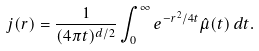<formula> <loc_0><loc_0><loc_500><loc_500>j ( r ) = \frac { 1 } { ( 4 \pi t ) ^ { d / 2 } } \int _ { 0 } ^ { \infty } e ^ { - r ^ { 2 } / 4 t } \hat { \mu } ( t ) \, d t .</formula> 